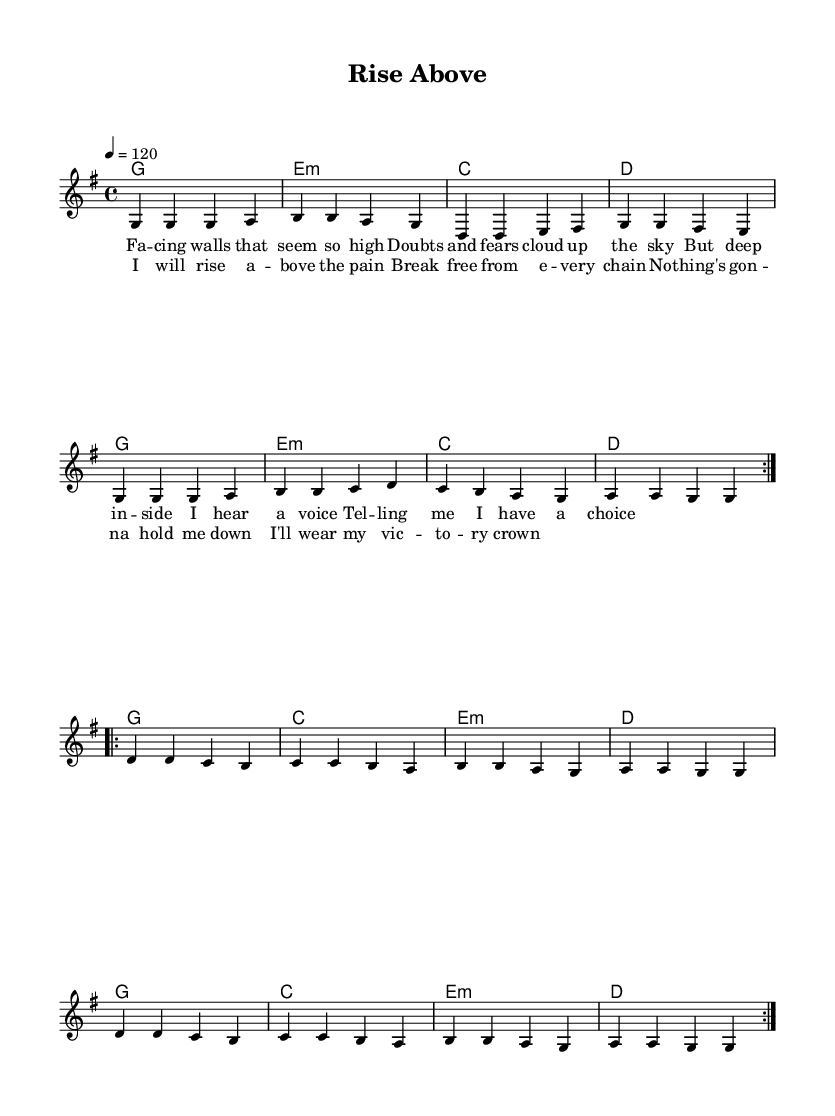What is the key signature of this music? The key signature is G major, which has one sharp (F#). This is indicated at the beginning of the sheet music where the key is stated.
Answer: G major What is the time signature of this music? The time signature is 4/4, which means there are four beats in each measure, as shown in the sheet music. It is located at the start of the staff.
Answer: 4/4 What is the tempo marking for this piece? The piece is marked at a tempo of 120 beats per minute, noted in the tempo indication of the score. This indicates how fast the music should be played.
Answer: 120 How many measures are in the chorus section? The chorus consists of two measures, as seen when examining the lyrics and music notation. Each set of lyrics aligns with the notes, and only two measures are shown for that section.
Answer: 2 What chord is used at the beginning of the harmony? The first chord is G major, which can be identified at the beginning of the harmony line. It is represented clearly, corresponding to the G key signature.
Answer: G Which is the last note of the melody? The last note of the melody is G, located at the end of the repeat section indicated in the score. You can see that it returns to the 'g' note after the last measure.
Answer: G What is the primary theme conveyed in the lyrics? The primary theme is about overcoming challenges, as evidenced by phrases like "I will rise above the pain" within the lyrics. This theme of resilience and triumph is central to the song.
Answer: Overcoming challenges 